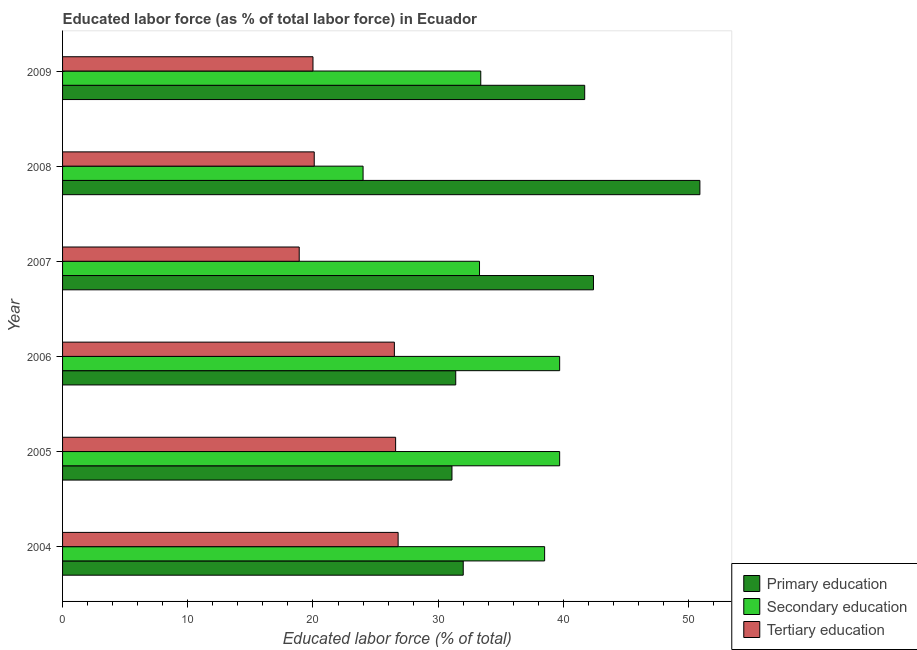Are the number of bars per tick equal to the number of legend labels?
Offer a very short reply. Yes. How many bars are there on the 1st tick from the bottom?
Your answer should be very brief. 3. Across all years, what is the maximum percentage of labor force who received primary education?
Offer a very short reply. 50.9. Across all years, what is the minimum percentage of labor force who received primary education?
Offer a very short reply. 31.1. In which year was the percentage of labor force who received primary education maximum?
Your answer should be compact. 2008. In which year was the percentage of labor force who received tertiary education minimum?
Ensure brevity in your answer.  2007. What is the total percentage of labor force who received secondary education in the graph?
Your answer should be compact. 208.6. What is the difference between the percentage of labor force who received tertiary education in 2006 and the percentage of labor force who received primary education in 2009?
Provide a succinct answer. -15.2. What is the average percentage of labor force who received tertiary education per year?
Keep it short and to the point. 23.15. What is the ratio of the percentage of labor force who received secondary education in 2005 to that in 2008?
Provide a succinct answer. 1.65. Is the difference between the percentage of labor force who received tertiary education in 2006 and 2007 greater than the difference between the percentage of labor force who received primary education in 2006 and 2007?
Offer a terse response. Yes. What is the difference between the highest and the second highest percentage of labor force who received secondary education?
Your answer should be very brief. 0. What is the difference between the highest and the lowest percentage of labor force who received secondary education?
Your answer should be compact. 15.7. In how many years, is the percentage of labor force who received secondary education greater than the average percentage of labor force who received secondary education taken over all years?
Your answer should be very brief. 3. Is the sum of the percentage of labor force who received primary education in 2006 and 2008 greater than the maximum percentage of labor force who received tertiary education across all years?
Offer a terse response. Yes. What does the 2nd bar from the top in 2007 represents?
Keep it short and to the point. Secondary education. Is it the case that in every year, the sum of the percentage of labor force who received primary education and percentage of labor force who received secondary education is greater than the percentage of labor force who received tertiary education?
Provide a short and direct response. Yes. Are all the bars in the graph horizontal?
Ensure brevity in your answer.  Yes. What is the difference between two consecutive major ticks on the X-axis?
Make the answer very short. 10. Are the values on the major ticks of X-axis written in scientific E-notation?
Provide a short and direct response. No. Does the graph contain grids?
Ensure brevity in your answer.  No. Where does the legend appear in the graph?
Give a very brief answer. Bottom right. What is the title of the graph?
Give a very brief answer. Educated labor force (as % of total labor force) in Ecuador. Does "Hydroelectric sources" appear as one of the legend labels in the graph?
Give a very brief answer. No. What is the label or title of the X-axis?
Offer a terse response. Educated labor force (% of total). What is the label or title of the Y-axis?
Offer a terse response. Year. What is the Educated labor force (% of total) in Primary education in 2004?
Your response must be concise. 32. What is the Educated labor force (% of total) of Secondary education in 2004?
Give a very brief answer. 38.5. What is the Educated labor force (% of total) in Tertiary education in 2004?
Provide a succinct answer. 26.8. What is the Educated labor force (% of total) of Primary education in 2005?
Provide a short and direct response. 31.1. What is the Educated labor force (% of total) of Secondary education in 2005?
Keep it short and to the point. 39.7. What is the Educated labor force (% of total) in Tertiary education in 2005?
Your answer should be compact. 26.6. What is the Educated labor force (% of total) of Primary education in 2006?
Ensure brevity in your answer.  31.4. What is the Educated labor force (% of total) in Secondary education in 2006?
Your response must be concise. 39.7. What is the Educated labor force (% of total) of Primary education in 2007?
Ensure brevity in your answer.  42.4. What is the Educated labor force (% of total) of Secondary education in 2007?
Offer a terse response. 33.3. What is the Educated labor force (% of total) of Tertiary education in 2007?
Give a very brief answer. 18.9. What is the Educated labor force (% of total) of Primary education in 2008?
Provide a short and direct response. 50.9. What is the Educated labor force (% of total) in Tertiary education in 2008?
Your answer should be very brief. 20.1. What is the Educated labor force (% of total) of Primary education in 2009?
Offer a very short reply. 41.7. What is the Educated labor force (% of total) of Secondary education in 2009?
Offer a very short reply. 33.4. Across all years, what is the maximum Educated labor force (% of total) of Primary education?
Offer a very short reply. 50.9. Across all years, what is the maximum Educated labor force (% of total) of Secondary education?
Provide a short and direct response. 39.7. Across all years, what is the maximum Educated labor force (% of total) in Tertiary education?
Offer a terse response. 26.8. Across all years, what is the minimum Educated labor force (% of total) in Primary education?
Provide a succinct answer. 31.1. Across all years, what is the minimum Educated labor force (% of total) of Secondary education?
Your answer should be very brief. 24. Across all years, what is the minimum Educated labor force (% of total) of Tertiary education?
Your answer should be compact. 18.9. What is the total Educated labor force (% of total) in Primary education in the graph?
Offer a terse response. 229.5. What is the total Educated labor force (% of total) of Secondary education in the graph?
Your response must be concise. 208.6. What is the total Educated labor force (% of total) of Tertiary education in the graph?
Ensure brevity in your answer.  138.9. What is the difference between the Educated labor force (% of total) of Primary education in 2004 and that in 2006?
Keep it short and to the point. 0.6. What is the difference between the Educated labor force (% of total) of Secondary education in 2004 and that in 2006?
Ensure brevity in your answer.  -1.2. What is the difference between the Educated labor force (% of total) in Tertiary education in 2004 and that in 2006?
Make the answer very short. 0.3. What is the difference between the Educated labor force (% of total) in Primary education in 2004 and that in 2008?
Your response must be concise. -18.9. What is the difference between the Educated labor force (% of total) in Secondary education in 2004 and that in 2008?
Give a very brief answer. 14.5. What is the difference between the Educated labor force (% of total) in Primary education in 2004 and that in 2009?
Your answer should be compact. -9.7. What is the difference between the Educated labor force (% of total) of Secondary education in 2004 and that in 2009?
Give a very brief answer. 5.1. What is the difference between the Educated labor force (% of total) of Secondary education in 2005 and that in 2006?
Your answer should be very brief. 0. What is the difference between the Educated labor force (% of total) in Primary education in 2005 and that in 2007?
Provide a succinct answer. -11.3. What is the difference between the Educated labor force (% of total) of Primary education in 2005 and that in 2008?
Your answer should be very brief. -19.8. What is the difference between the Educated labor force (% of total) of Tertiary education in 2005 and that in 2008?
Give a very brief answer. 6.5. What is the difference between the Educated labor force (% of total) of Primary education in 2005 and that in 2009?
Provide a succinct answer. -10.6. What is the difference between the Educated labor force (% of total) of Secondary education in 2005 and that in 2009?
Offer a very short reply. 6.3. What is the difference between the Educated labor force (% of total) in Primary education in 2006 and that in 2008?
Give a very brief answer. -19.5. What is the difference between the Educated labor force (% of total) in Secondary education in 2006 and that in 2008?
Make the answer very short. 15.7. What is the difference between the Educated labor force (% of total) in Tertiary education in 2006 and that in 2008?
Keep it short and to the point. 6.4. What is the difference between the Educated labor force (% of total) in Primary education in 2006 and that in 2009?
Offer a very short reply. -10.3. What is the difference between the Educated labor force (% of total) in Secondary education in 2006 and that in 2009?
Give a very brief answer. 6.3. What is the difference between the Educated labor force (% of total) in Primary education in 2007 and that in 2008?
Your answer should be compact. -8.5. What is the difference between the Educated labor force (% of total) in Tertiary education in 2007 and that in 2008?
Provide a short and direct response. -1.2. What is the difference between the Educated labor force (% of total) in Tertiary education in 2007 and that in 2009?
Keep it short and to the point. -1.1. What is the difference between the Educated labor force (% of total) in Primary education in 2008 and that in 2009?
Offer a terse response. 9.2. What is the difference between the Educated labor force (% of total) in Secondary education in 2008 and that in 2009?
Offer a very short reply. -9.4. What is the difference between the Educated labor force (% of total) of Primary education in 2004 and the Educated labor force (% of total) of Secondary education in 2005?
Make the answer very short. -7.7. What is the difference between the Educated labor force (% of total) of Secondary education in 2004 and the Educated labor force (% of total) of Tertiary education in 2005?
Your response must be concise. 11.9. What is the difference between the Educated labor force (% of total) of Primary education in 2004 and the Educated labor force (% of total) of Secondary education in 2006?
Keep it short and to the point. -7.7. What is the difference between the Educated labor force (% of total) in Primary education in 2004 and the Educated labor force (% of total) in Tertiary education in 2006?
Ensure brevity in your answer.  5.5. What is the difference between the Educated labor force (% of total) of Secondary education in 2004 and the Educated labor force (% of total) of Tertiary education in 2006?
Provide a short and direct response. 12. What is the difference between the Educated labor force (% of total) in Primary education in 2004 and the Educated labor force (% of total) in Secondary education in 2007?
Your answer should be very brief. -1.3. What is the difference between the Educated labor force (% of total) in Secondary education in 2004 and the Educated labor force (% of total) in Tertiary education in 2007?
Keep it short and to the point. 19.6. What is the difference between the Educated labor force (% of total) in Primary education in 2004 and the Educated labor force (% of total) in Tertiary education in 2008?
Make the answer very short. 11.9. What is the difference between the Educated labor force (% of total) in Secondary education in 2004 and the Educated labor force (% of total) in Tertiary education in 2009?
Keep it short and to the point. 18.5. What is the difference between the Educated labor force (% of total) in Secondary education in 2005 and the Educated labor force (% of total) in Tertiary education in 2006?
Keep it short and to the point. 13.2. What is the difference between the Educated labor force (% of total) of Primary education in 2005 and the Educated labor force (% of total) of Tertiary education in 2007?
Provide a short and direct response. 12.2. What is the difference between the Educated labor force (% of total) of Secondary education in 2005 and the Educated labor force (% of total) of Tertiary education in 2007?
Offer a terse response. 20.8. What is the difference between the Educated labor force (% of total) of Secondary education in 2005 and the Educated labor force (% of total) of Tertiary education in 2008?
Keep it short and to the point. 19.6. What is the difference between the Educated labor force (% of total) in Primary education in 2005 and the Educated labor force (% of total) in Secondary education in 2009?
Provide a succinct answer. -2.3. What is the difference between the Educated labor force (% of total) of Primary education in 2006 and the Educated labor force (% of total) of Secondary education in 2007?
Offer a terse response. -1.9. What is the difference between the Educated labor force (% of total) of Primary education in 2006 and the Educated labor force (% of total) of Tertiary education in 2007?
Provide a short and direct response. 12.5. What is the difference between the Educated labor force (% of total) in Secondary education in 2006 and the Educated labor force (% of total) in Tertiary education in 2007?
Provide a short and direct response. 20.8. What is the difference between the Educated labor force (% of total) in Primary education in 2006 and the Educated labor force (% of total) in Tertiary education in 2008?
Give a very brief answer. 11.3. What is the difference between the Educated labor force (% of total) of Secondary education in 2006 and the Educated labor force (% of total) of Tertiary education in 2008?
Ensure brevity in your answer.  19.6. What is the difference between the Educated labor force (% of total) of Primary education in 2006 and the Educated labor force (% of total) of Secondary education in 2009?
Ensure brevity in your answer.  -2. What is the difference between the Educated labor force (% of total) of Secondary education in 2006 and the Educated labor force (% of total) of Tertiary education in 2009?
Make the answer very short. 19.7. What is the difference between the Educated labor force (% of total) in Primary education in 2007 and the Educated labor force (% of total) in Tertiary education in 2008?
Give a very brief answer. 22.3. What is the difference between the Educated labor force (% of total) in Primary education in 2007 and the Educated labor force (% of total) in Tertiary education in 2009?
Give a very brief answer. 22.4. What is the difference between the Educated labor force (% of total) of Primary education in 2008 and the Educated labor force (% of total) of Secondary education in 2009?
Ensure brevity in your answer.  17.5. What is the difference between the Educated labor force (% of total) of Primary education in 2008 and the Educated labor force (% of total) of Tertiary education in 2009?
Offer a terse response. 30.9. What is the average Educated labor force (% of total) of Primary education per year?
Offer a very short reply. 38.25. What is the average Educated labor force (% of total) in Secondary education per year?
Your answer should be very brief. 34.77. What is the average Educated labor force (% of total) of Tertiary education per year?
Provide a short and direct response. 23.15. In the year 2004, what is the difference between the Educated labor force (% of total) of Primary education and Educated labor force (% of total) of Tertiary education?
Provide a succinct answer. 5.2. In the year 2004, what is the difference between the Educated labor force (% of total) of Secondary education and Educated labor force (% of total) of Tertiary education?
Provide a succinct answer. 11.7. In the year 2005, what is the difference between the Educated labor force (% of total) of Primary education and Educated labor force (% of total) of Tertiary education?
Offer a terse response. 4.5. In the year 2005, what is the difference between the Educated labor force (% of total) of Secondary education and Educated labor force (% of total) of Tertiary education?
Provide a succinct answer. 13.1. In the year 2006, what is the difference between the Educated labor force (% of total) of Primary education and Educated labor force (% of total) of Secondary education?
Provide a short and direct response. -8.3. In the year 2006, what is the difference between the Educated labor force (% of total) of Primary education and Educated labor force (% of total) of Tertiary education?
Your answer should be compact. 4.9. In the year 2007, what is the difference between the Educated labor force (% of total) in Primary education and Educated labor force (% of total) in Tertiary education?
Give a very brief answer. 23.5. In the year 2007, what is the difference between the Educated labor force (% of total) in Secondary education and Educated labor force (% of total) in Tertiary education?
Your answer should be compact. 14.4. In the year 2008, what is the difference between the Educated labor force (% of total) of Primary education and Educated labor force (% of total) of Secondary education?
Provide a short and direct response. 26.9. In the year 2008, what is the difference between the Educated labor force (% of total) of Primary education and Educated labor force (% of total) of Tertiary education?
Keep it short and to the point. 30.8. In the year 2008, what is the difference between the Educated labor force (% of total) of Secondary education and Educated labor force (% of total) of Tertiary education?
Provide a short and direct response. 3.9. In the year 2009, what is the difference between the Educated labor force (% of total) of Primary education and Educated labor force (% of total) of Secondary education?
Provide a succinct answer. 8.3. In the year 2009, what is the difference between the Educated labor force (% of total) in Primary education and Educated labor force (% of total) in Tertiary education?
Give a very brief answer. 21.7. What is the ratio of the Educated labor force (% of total) of Primary education in 2004 to that in 2005?
Your answer should be compact. 1.03. What is the ratio of the Educated labor force (% of total) in Secondary education in 2004 to that in 2005?
Ensure brevity in your answer.  0.97. What is the ratio of the Educated labor force (% of total) of Tertiary education in 2004 to that in 2005?
Offer a terse response. 1.01. What is the ratio of the Educated labor force (% of total) of Primary education in 2004 to that in 2006?
Provide a short and direct response. 1.02. What is the ratio of the Educated labor force (% of total) in Secondary education in 2004 to that in 2006?
Give a very brief answer. 0.97. What is the ratio of the Educated labor force (% of total) of Tertiary education in 2004 to that in 2006?
Provide a succinct answer. 1.01. What is the ratio of the Educated labor force (% of total) in Primary education in 2004 to that in 2007?
Offer a terse response. 0.75. What is the ratio of the Educated labor force (% of total) of Secondary education in 2004 to that in 2007?
Offer a very short reply. 1.16. What is the ratio of the Educated labor force (% of total) of Tertiary education in 2004 to that in 2007?
Make the answer very short. 1.42. What is the ratio of the Educated labor force (% of total) in Primary education in 2004 to that in 2008?
Keep it short and to the point. 0.63. What is the ratio of the Educated labor force (% of total) in Secondary education in 2004 to that in 2008?
Provide a short and direct response. 1.6. What is the ratio of the Educated labor force (% of total) in Primary education in 2004 to that in 2009?
Make the answer very short. 0.77. What is the ratio of the Educated labor force (% of total) in Secondary education in 2004 to that in 2009?
Make the answer very short. 1.15. What is the ratio of the Educated labor force (% of total) of Tertiary education in 2004 to that in 2009?
Provide a succinct answer. 1.34. What is the ratio of the Educated labor force (% of total) of Primary education in 2005 to that in 2006?
Make the answer very short. 0.99. What is the ratio of the Educated labor force (% of total) of Primary education in 2005 to that in 2007?
Provide a succinct answer. 0.73. What is the ratio of the Educated labor force (% of total) of Secondary education in 2005 to that in 2007?
Make the answer very short. 1.19. What is the ratio of the Educated labor force (% of total) in Tertiary education in 2005 to that in 2007?
Give a very brief answer. 1.41. What is the ratio of the Educated labor force (% of total) in Primary education in 2005 to that in 2008?
Offer a terse response. 0.61. What is the ratio of the Educated labor force (% of total) of Secondary education in 2005 to that in 2008?
Your answer should be compact. 1.65. What is the ratio of the Educated labor force (% of total) in Tertiary education in 2005 to that in 2008?
Make the answer very short. 1.32. What is the ratio of the Educated labor force (% of total) of Primary education in 2005 to that in 2009?
Make the answer very short. 0.75. What is the ratio of the Educated labor force (% of total) of Secondary education in 2005 to that in 2009?
Give a very brief answer. 1.19. What is the ratio of the Educated labor force (% of total) of Tertiary education in 2005 to that in 2009?
Ensure brevity in your answer.  1.33. What is the ratio of the Educated labor force (% of total) of Primary education in 2006 to that in 2007?
Offer a terse response. 0.74. What is the ratio of the Educated labor force (% of total) of Secondary education in 2006 to that in 2007?
Provide a short and direct response. 1.19. What is the ratio of the Educated labor force (% of total) in Tertiary education in 2006 to that in 2007?
Your answer should be very brief. 1.4. What is the ratio of the Educated labor force (% of total) in Primary education in 2006 to that in 2008?
Provide a short and direct response. 0.62. What is the ratio of the Educated labor force (% of total) of Secondary education in 2006 to that in 2008?
Offer a terse response. 1.65. What is the ratio of the Educated labor force (% of total) in Tertiary education in 2006 to that in 2008?
Your response must be concise. 1.32. What is the ratio of the Educated labor force (% of total) of Primary education in 2006 to that in 2009?
Make the answer very short. 0.75. What is the ratio of the Educated labor force (% of total) of Secondary education in 2006 to that in 2009?
Offer a terse response. 1.19. What is the ratio of the Educated labor force (% of total) of Tertiary education in 2006 to that in 2009?
Your answer should be compact. 1.32. What is the ratio of the Educated labor force (% of total) in Primary education in 2007 to that in 2008?
Your answer should be very brief. 0.83. What is the ratio of the Educated labor force (% of total) in Secondary education in 2007 to that in 2008?
Provide a succinct answer. 1.39. What is the ratio of the Educated labor force (% of total) in Tertiary education in 2007 to that in 2008?
Your response must be concise. 0.94. What is the ratio of the Educated labor force (% of total) of Primary education in 2007 to that in 2009?
Give a very brief answer. 1.02. What is the ratio of the Educated labor force (% of total) in Secondary education in 2007 to that in 2009?
Offer a very short reply. 1. What is the ratio of the Educated labor force (% of total) in Tertiary education in 2007 to that in 2009?
Provide a short and direct response. 0.94. What is the ratio of the Educated labor force (% of total) in Primary education in 2008 to that in 2009?
Offer a very short reply. 1.22. What is the ratio of the Educated labor force (% of total) in Secondary education in 2008 to that in 2009?
Ensure brevity in your answer.  0.72. What is the ratio of the Educated labor force (% of total) of Tertiary education in 2008 to that in 2009?
Provide a short and direct response. 1. What is the difference between the highest and the second highest Educated labor force (% of total) in Primary education?
Your answer should be very brief. 8.5. What is the difference between the highest and the second highest Educated labor force (% of total) in Secondary education?
Your response must be concise. 0. What is the difference between the highest and the lowest Educated labor force (% of total) of Primary education?
Your answer should be compact. 19.8. 